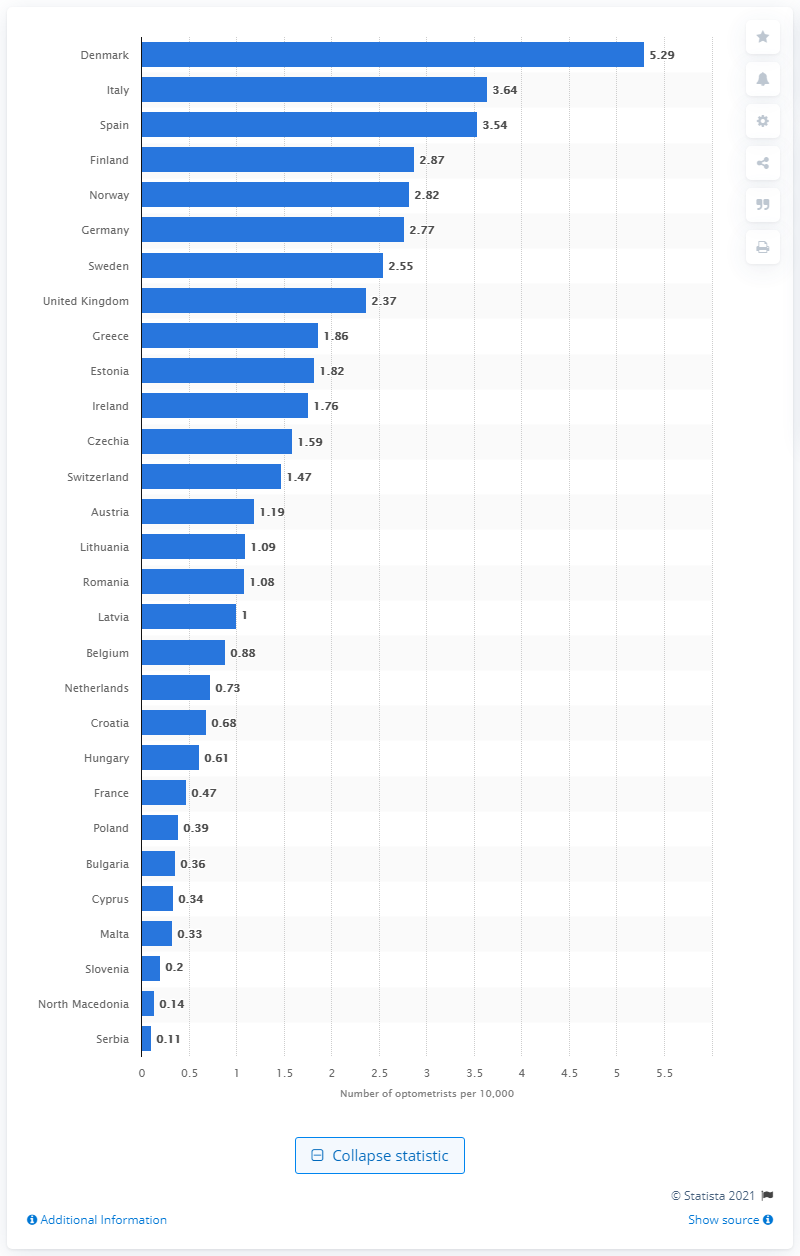Mention a couple of crucial points in this snapshot. According to data, Cyprus has the highest number of optician retail units per 10,000 population among all countries. In 2020, there were 5,29 optometrists per 10,000 population in Denmark. The country with the highest number of opticians per 10,000 inhabitants is France. 